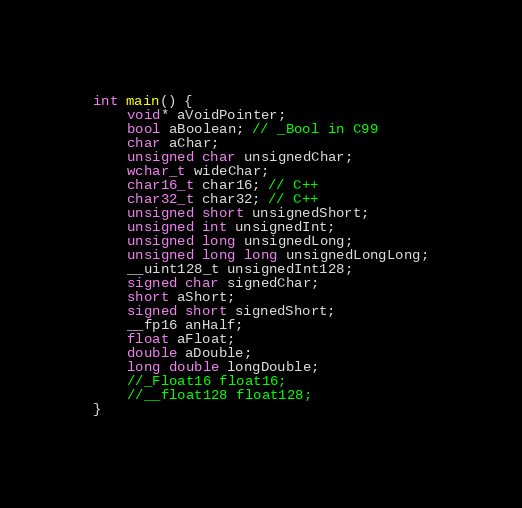<code> <loc_0><loc_0><loc_500><loc_500><_C++_>int main() {
	void* aVoidPointer;
	bool aBoolean; // _Bool in C99
	char aChar;
	unsigned char unsignedChar;
	wchar_t wideChar;
	char16_t char16; // C++
	char32_t char32; // C++
	unsigned short unsignedShort;
	unsigned int unsignedInt;
	unsigned long unsignedLong;
	unsigned long long unsignedLongLong;
	__uint128_t unsignedInt128;
	signed char signedChar;
	short aShort;
	signed short signedShort;
	__fp16 anHalf;
	float aFloat;
	double aDouble;
	long double longDouble;
	//_Float16 float16;
	//__float128 float128;
}</code> 